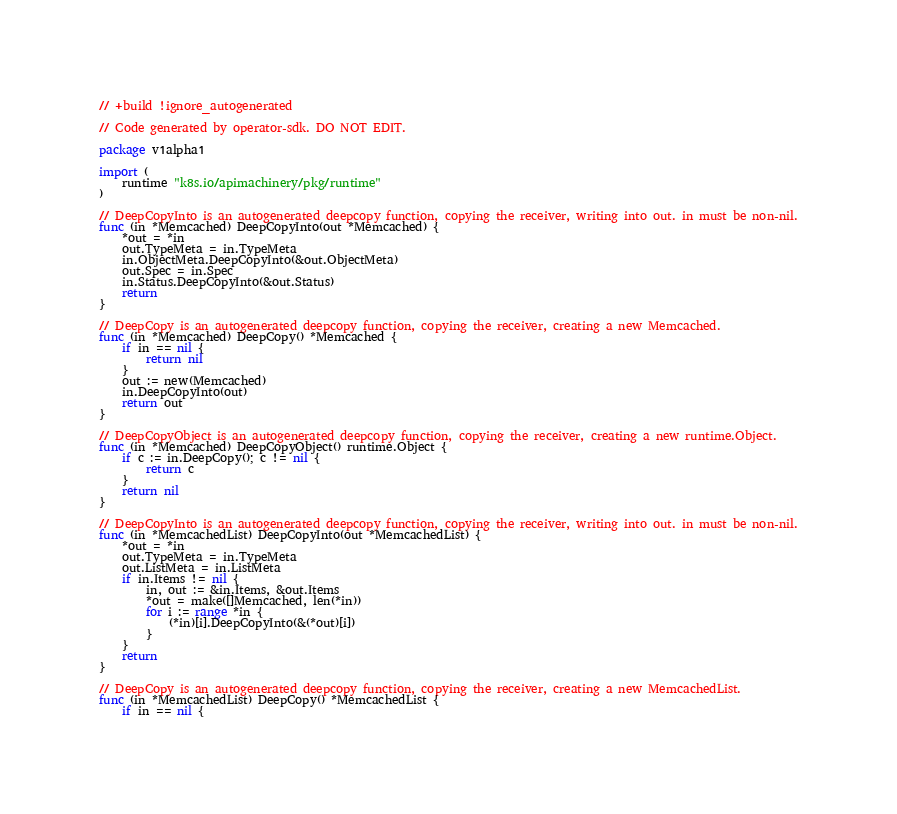<code> <loc_0><loc_0><loc_500><loc_500><_Go_>// +build !ignore_autogenerated

// Code generated by operator-sdk. DO NOT EDIT.

package v1alpha1

import (
	runtime "k8s.io/apimachinery/pkg/runtime"
)

// DeepCopyInto is an autogenerated deepcopy function, copying the receiver, writing into out. in must be non-nil.
func (in *Memcached) DeepCopyInto(out *Memcached) {
	*out = *in
	out.TypeMeta = in.TypeMeta
	in.ObjectMeta.DeepCopyInto(&out.ObjectMeta)
	out.Spec = in.Spec
	in.Status.DeepCopyInto(&out.Status)
	return
}

// DeepCopy is an autogenerated deepcopy function, copying the receiver, creating a new Memcached.
func (in *Memcached) DeepCopy() *Memcached {
	if in == nil {
		return nil
	}
	out := new(Memcached)
	in.DeepCopyInto(out)
	return out
}

// DeepCopyObject is an autogenerated deepcopy function, copying the receiver, creating a new runtime.Object.
func (in *Memcached) DeepCopyObject() runtime.Object {
	if c := in.DeepCopy(); c != nil {
		return c
	}
	return nil
}

// DeepCopyInto is an autogenerated deepcopy function, copying the receiver, writing into out. in must be non-nil.
func (in *MemcachedList) DeepCopyInto(out *MemcachedList) {
	*out = *in
	out.TypeMeta = in.TypeMeta
	out.ListMeta = in.ListMeta
	if in.Items != nil {
		in, out := &in.Items, &out.Items
		*out = make([]Memcached, len(*in))
		for i := range *in {
			(*in)[i].DeepCopyInto(&(*out)[i])
		}
	}
	return
}

// DeepCopy is an autogenerated deepcopy function, copying the receiver, creating a new MemcachedList.
func (in *MemcachedList) DeepCopy() *MemcachedList {
	if in == nil {</code> 